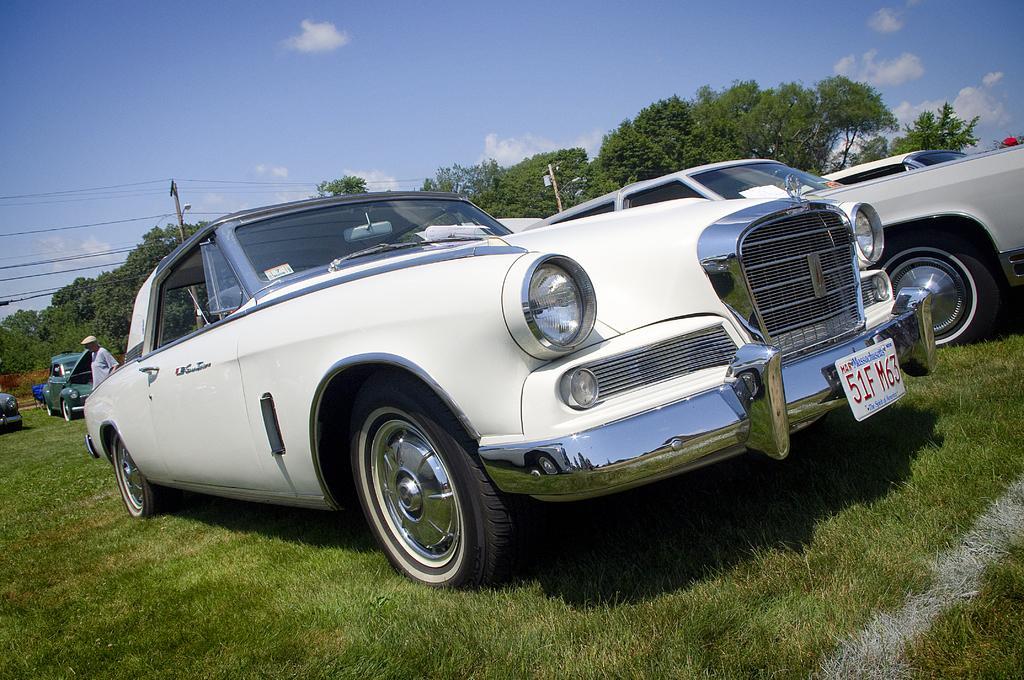Could you give a brief overview of what you see in this image? In this image we can see vehicles, person and other objects. In the background of the image there are trees, poles and other objects. At the top of the image there is the sky. At the bottom of the image there is the grass. 